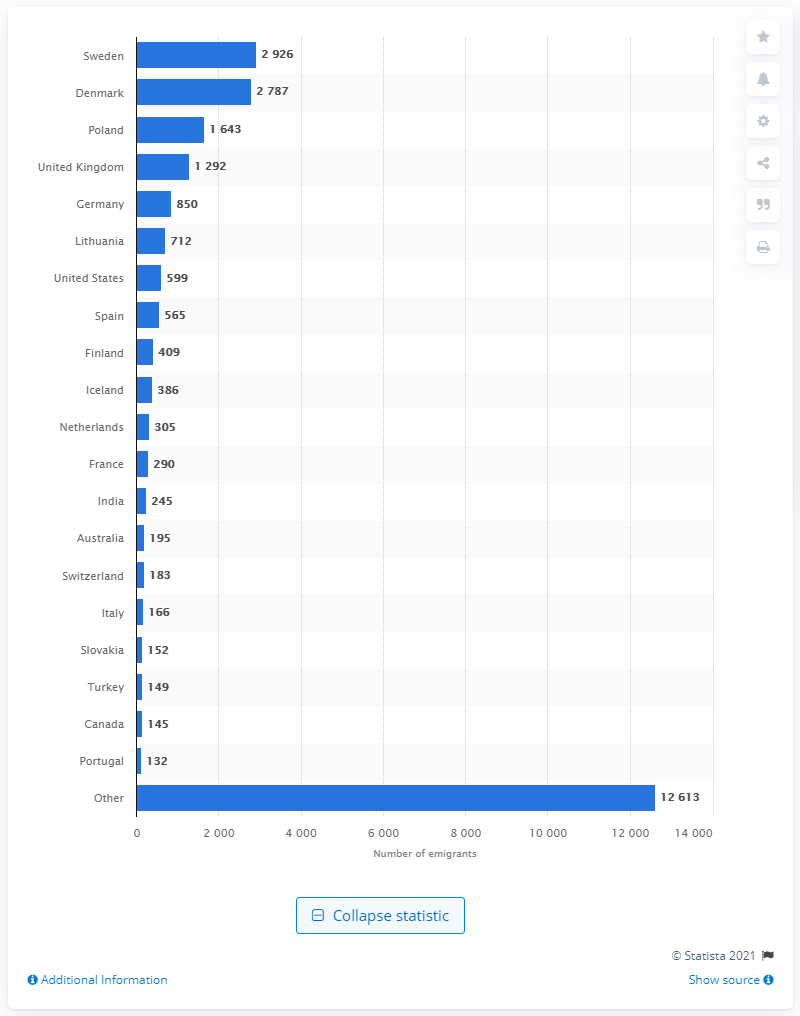Specify some key components in this picture. Denmark had the second highest number of emigrants in 2020. 